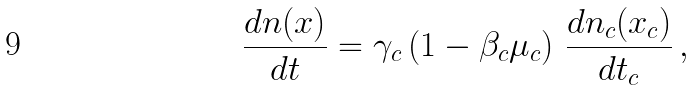Convert formula to latex. <formula><loc_0><loc_0><loc_500><loc_500>\frac { d n ( x ) } { d t } = \gamma _ { c } \left ( 1 - \beta _ { c } \mu _ { c } \right ) \, \frac { d n _ { c } ( x _ { c } ) } { d t _ { c } } \, ,</formula> 